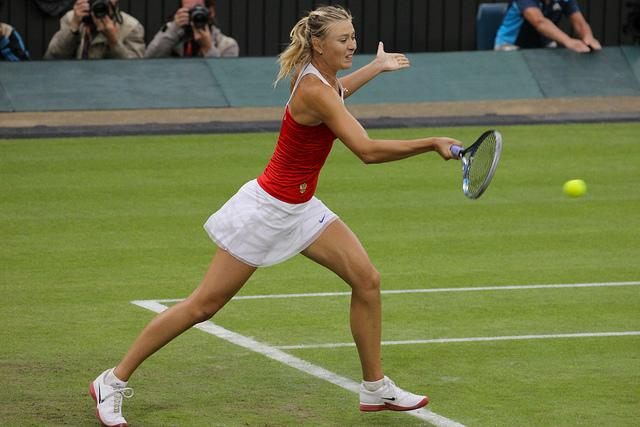What type of shot is the woman hitting? Please explain your reasoning. forehand. The shot uses the forehand. 